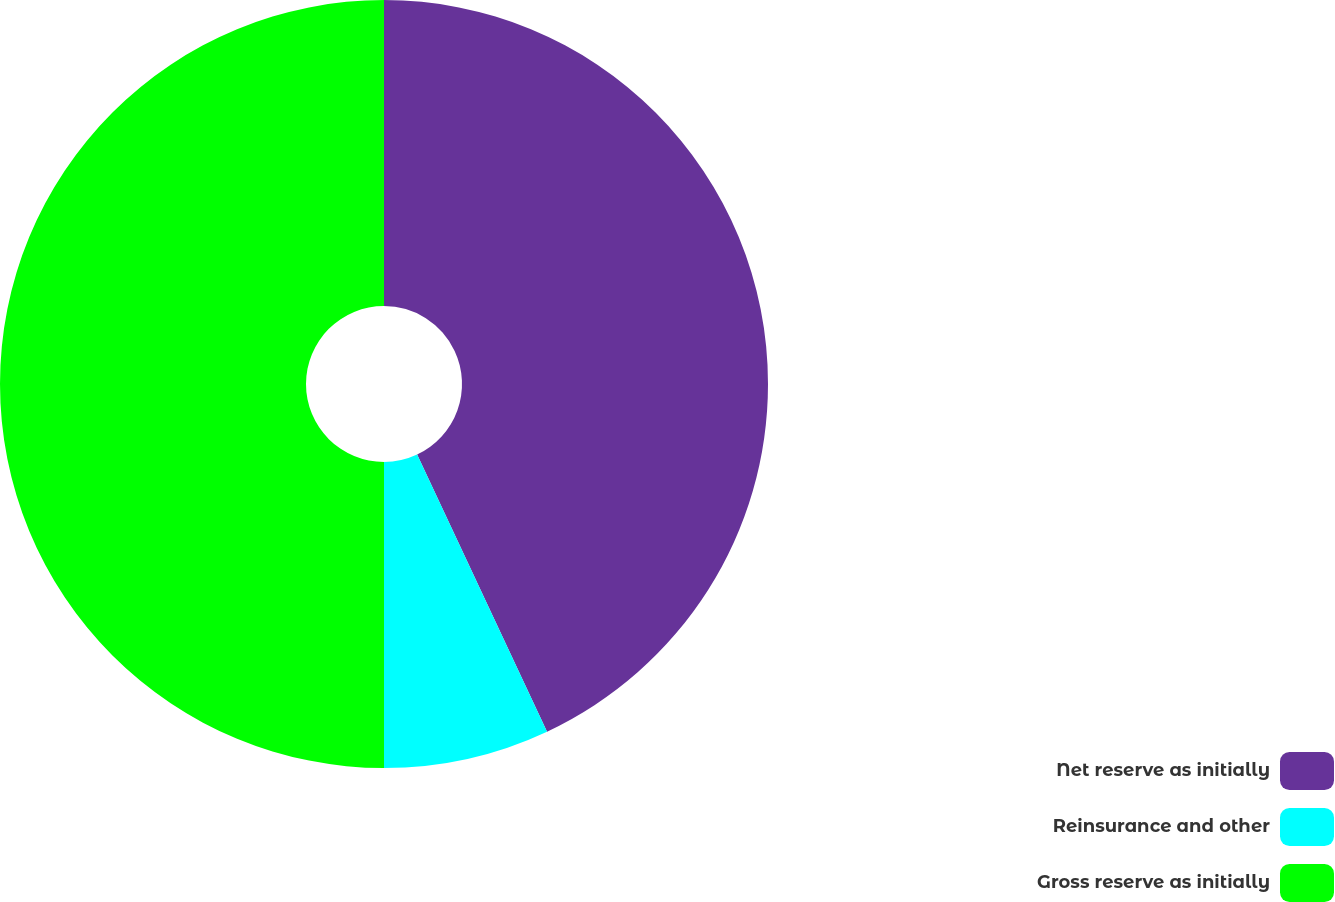Convert chart. <chart><loc_0><loc_0><loc_500><loc_500><pie_chart><fcel>Net reserve as initially<fcel>Reinsurance and other<fcel>Gross reserve as initially<nl><fcel>43.02%<fcel>6.98%<fcel>50.0%<nl></chart> 